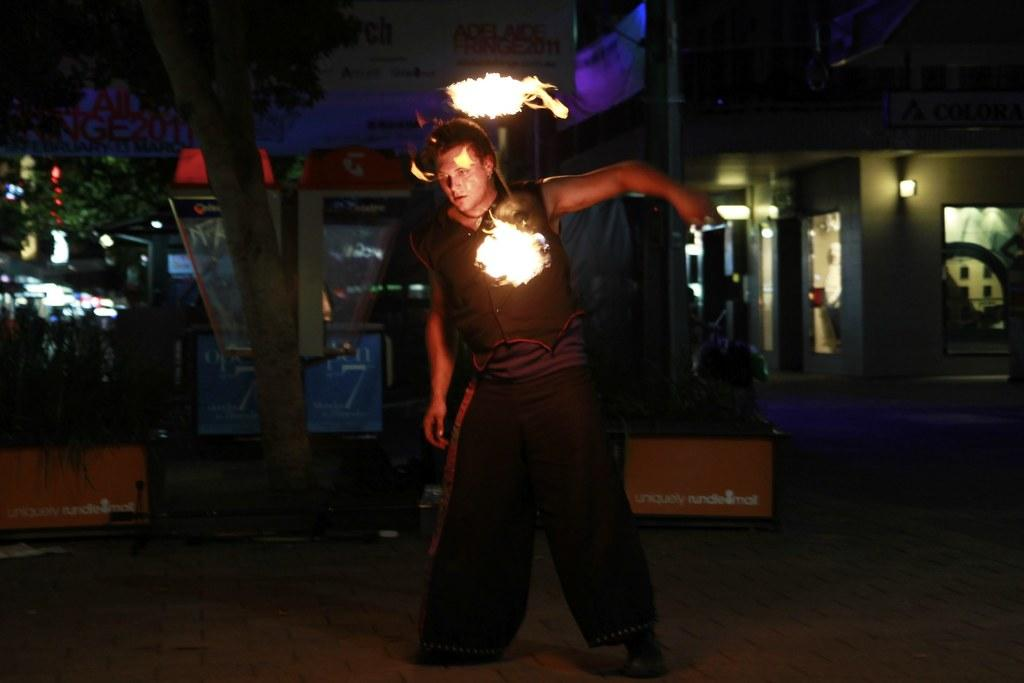What is the main subject of the image? There is a person standing in the image. What can be seen in the foreground of the image? Fire is visible in the image. What is visible in the background of the image? There are stalls, buildings, lights, and trees present in the background of the image. How many ladybugs can be seen on the person's shoulder in the image? There are no ladybugs present on the person's shoulder in the image. What type of agreement is being discussed by the person in the image? There is no indication of any agreement being discussed in the image. 